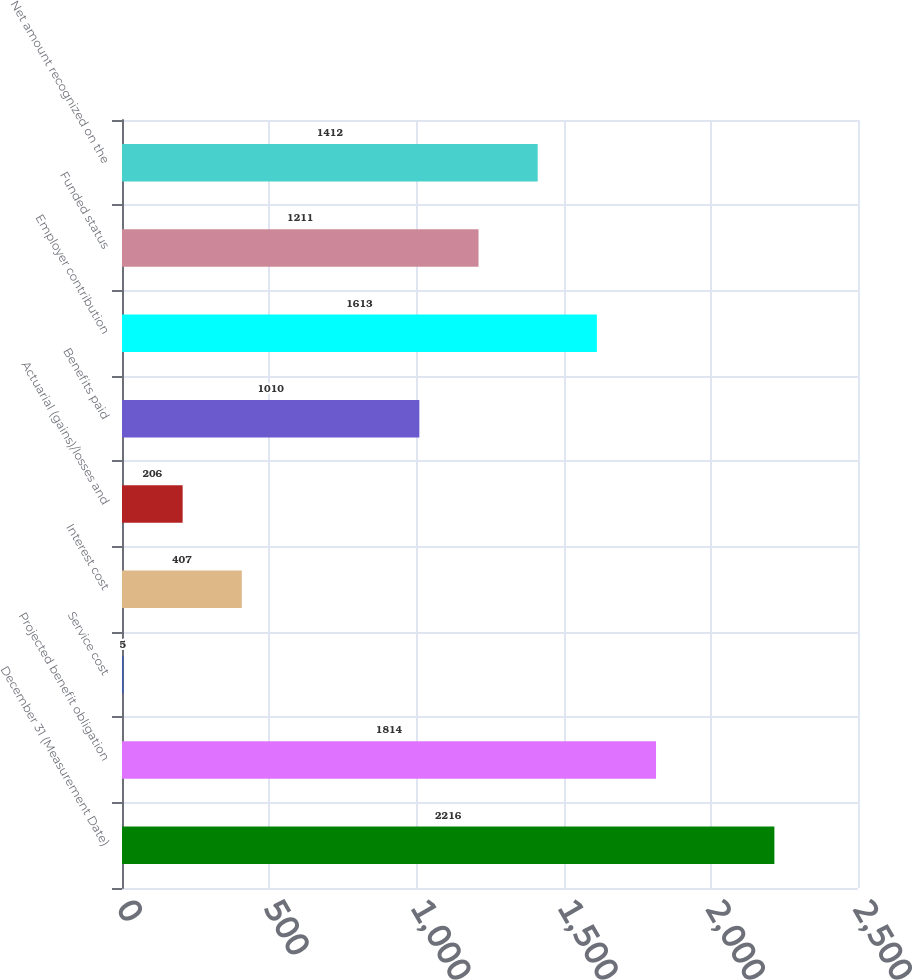Convert chart to OTSL. <chart><loc_0><loc_0><loc_500><loc_500><bar_chart><fcel>December 31 (Measurement Date)<fcel>Projected benefit obligation<fcel>Service cost<fcel>Interest cost<fcel>Actuarial (gains)/losses and<fcel>Benefits paid<fcel>Employer contribution<fcel>Funded status<fcel>Net amount recognized on the<nl><fcel>2216<fcel>1814<fcel>5<fcel>407<fcel>206<fcel>1010<fcel>1613<fcel>1211<fcel>1412<nl></chart> 